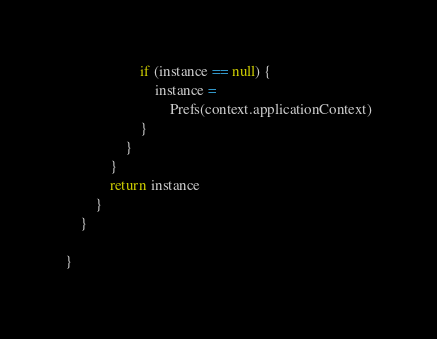<code> <loc_0><loc_0><loc_500><loc_500><_Kotlin_>                    if (instance == null) {
                        instance =
                            Prefs(context.applicationContext)
                    }
                }
            }
            return instance
        }
    }

}</code> 